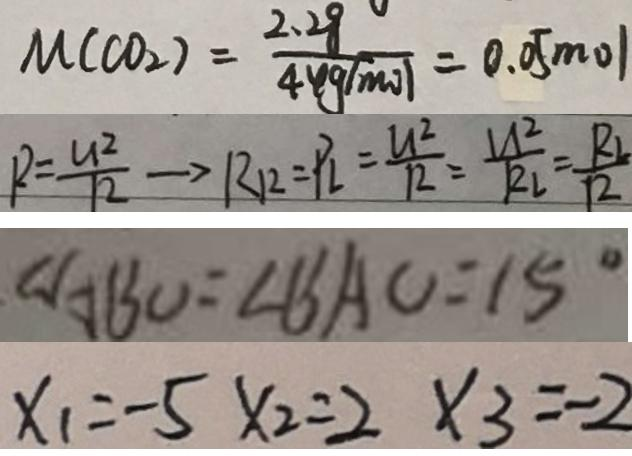Convert formula to latex. <formula><loc_0><loc_0><loc_500><loc_500>M ( C O _ { 2 } ) = \frac { 2 . 2 8 } { 4 4 9 ( m o ) } = 0 . 0 5 m o l 
 R = \frac { U ^ { 2 } } { 1 2 } \rightarrow R _ { 1 2 } = P _ { L } = \frac { U ^ { 2 } } { R } = \frac { U ^ { 2 } } { R _ { L } } = \frac { R _ { L } } { 1 2 } 
 \angle A B O = \angle B A O = 1 5 ^ { \circ } 
 x _ { 1 } = - 5 x _ { 2 } = 2 x _ { 3 } = - 2</formula> 